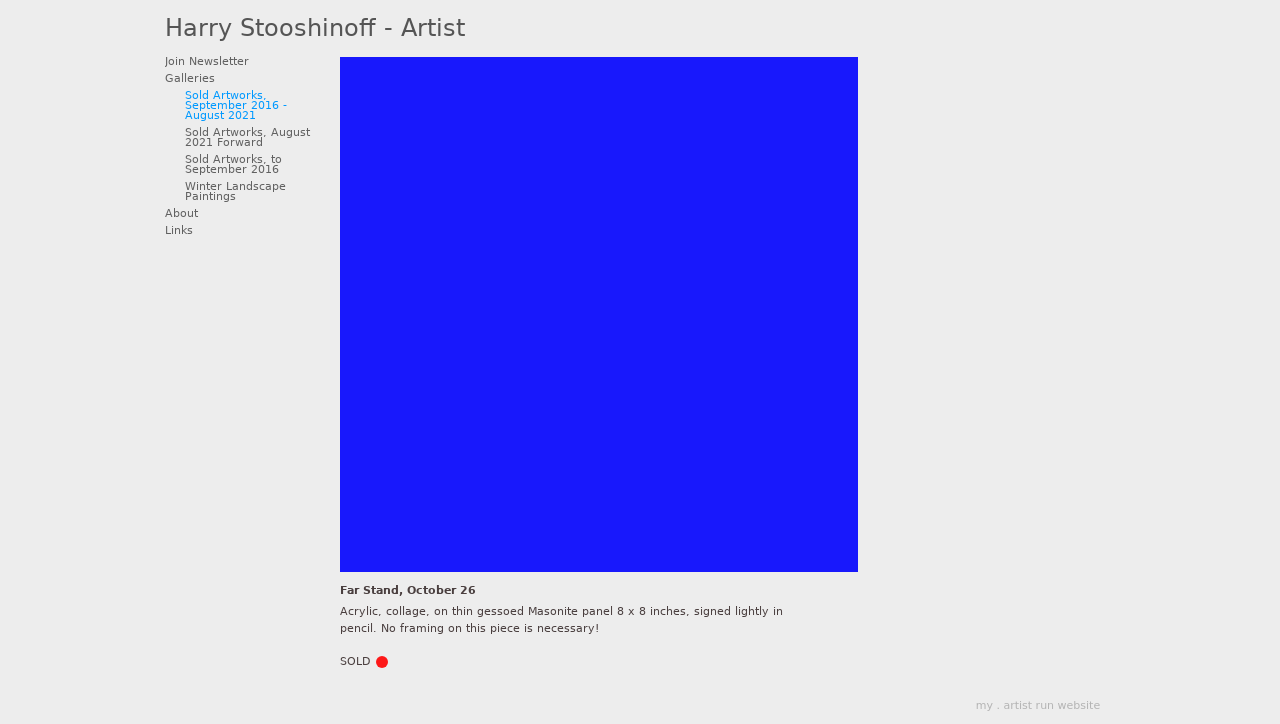Can you tell me more about the specific artwork 'Far Stand, October 26' shown in this image? The artwork titled 'Far Stand, October 26' is an acrylic and collage work on a thin gessoed Masonite panel measuring 8 x 8 inches. It's part of Harry Stooshinoff's collection and has been signed lightly in pencil. A distinctive feature of this piece is that no framing is required as it adheres to a wooden back support designed to allow the artwork to hang flat against a wall.  How does the choice of materials affect the presentation of the artwork? The choice of materials in 'Far Stand, October 26', particularly the thin gessoed Masonite panel and acrylic, provide a sturdy yet lightweight base that enhances the vibrancy of the colors used. The collage elements add texture and dimension, making the artwork stand out more vividly. The wooden back support offers a practical and aesthetically pleasing way to display the piece without the need for a traditional frame. 